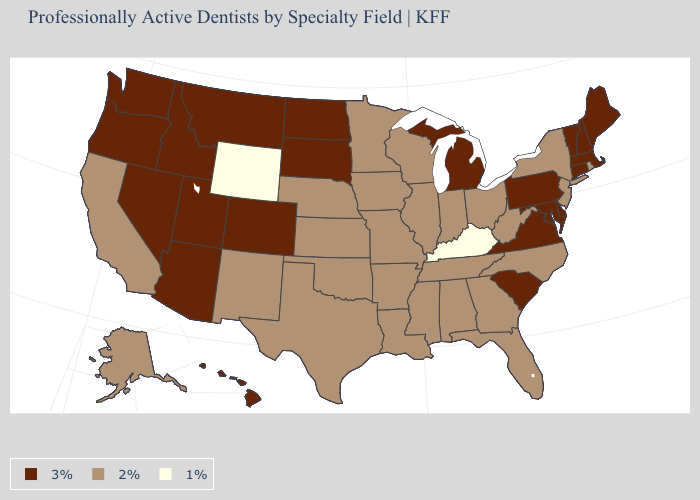Among the states that border Oklahoma , does Kansas have the highest value?
Concise answer only. No. Among the states that border Montana , does Idaho have the lowest value?
Concise answer only. No. What is the value of Alaska?
Be succinct. 2%. Which states have the lowest value in the USA?
Quick response, please. Kentucky, Wyoming. What is the highest value in the Northeast ?
Answer briefly. 3%. Which states have the lowest value in the USA?
Write a very short answer. Kentucky, Wyoming. Does Ohio have the highest value in the MidWest?
Short answer required. No. Among the states that border Arkansas , which have the highest value?
Answer briefly. Louisiana, Mississippi, Missouri, Oklahoma, Tennessee, Texas. What is the value of Colorado?
Be succinct. 3%. What is the highest value in states that border Mississippi?
Be succinct. 2%. What is the value of Arizona?
Be succinct. 3%. Does the map have missing data?
Short answer required. No. 